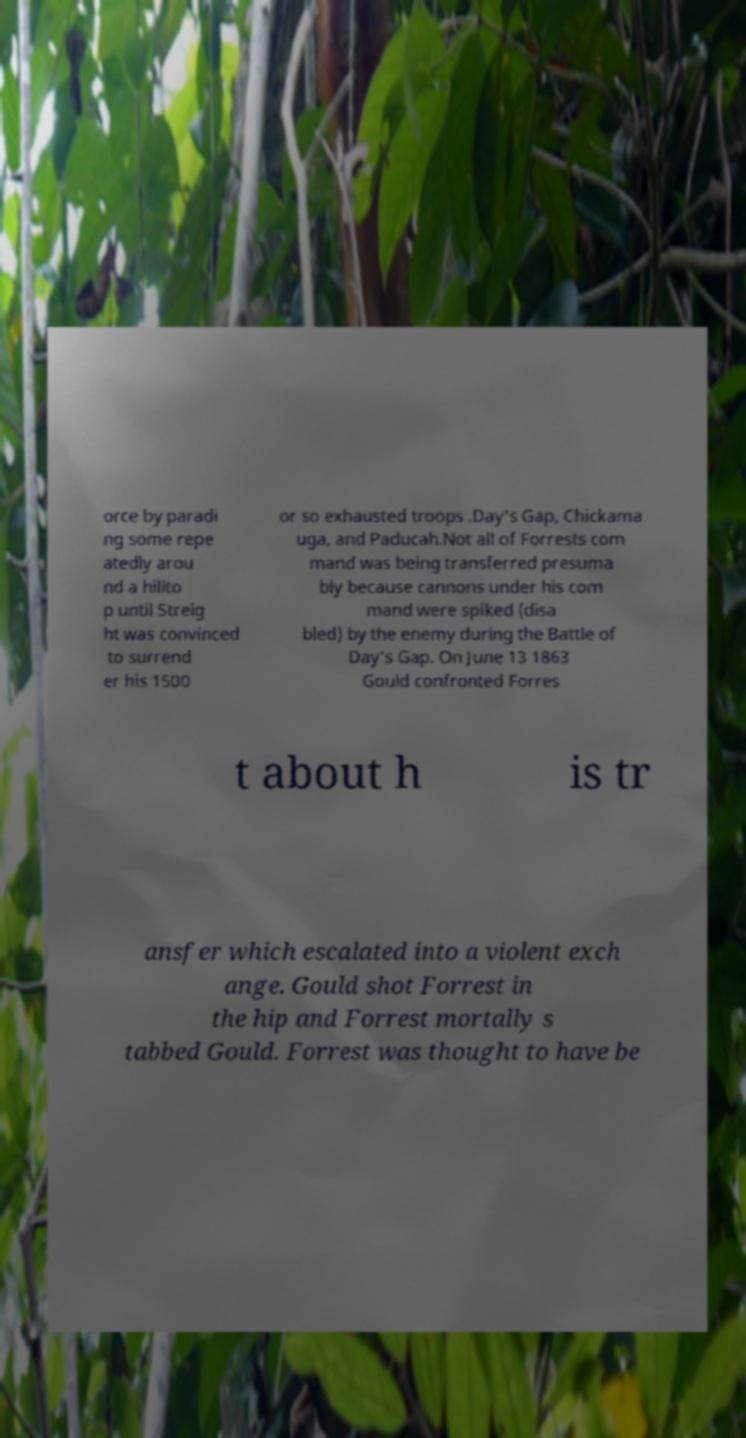There's text embedded in this image that I need extracted. Can you transcribe it verbatim? orce by paradi ng some repe atedly arou nd a hillto p until Streig ht was convinced to surrend er his 1500 or so exhausted troops .Day's Gap, Chickama uga, and Paducah.Not all of Forrests com mand was being transferred presuma bly because cannons under his com mand were spiked (disa bled) by the enemy during the Battle of Day's Gap. On June 13 1863 Gould confronted Forres t about h is tr ansfer which escalated into a violent exch ange. Gould shot Forrest in the hip and Forrest mortally s tabbed Gould. Forrest was thought to have be 